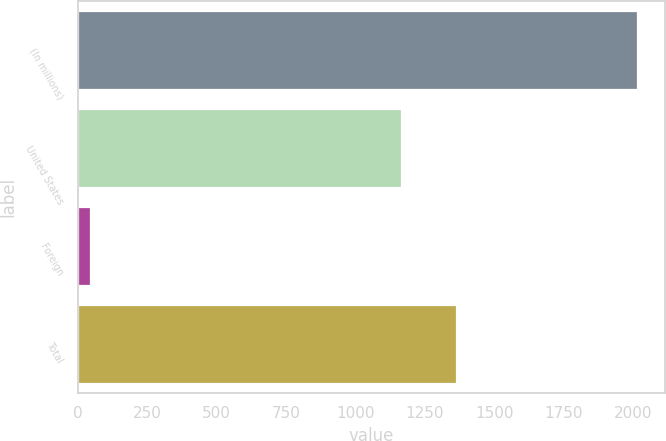<chart> <loc_0><loc_0><loc_500><loc_500><bar_chart><fcel>(In millions)<fcel>United States<fcel>Foreign<fcel>Total<nl><fcel>2013<fcel>1165<fcel>45<fcel>1361.8<nl></chart> 